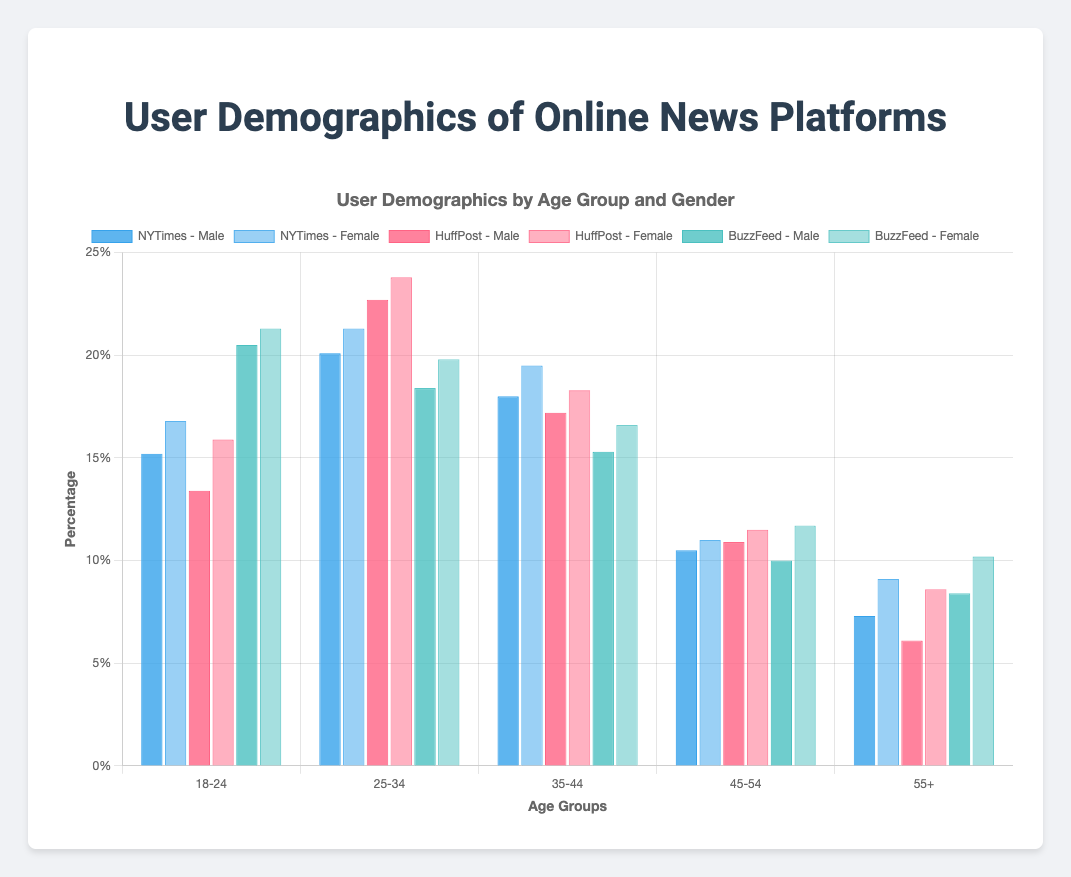Which platform has the highest percentage of users in the 18-24 age group for both genders combined? To find the platform with the highest percentage of users in the 18-24 age group for both genders combined, add the percentages for males and females for each platform in this age group. For NYTimes, it's 15.2% (male) + 16.8% (female) = 32%. For HuffPost, it's 13.4% (male) + 15.9% (female) = 29.3%. For BuzzFeed, it's 20.5% (male) + 21.3% (female) = 41.8%. Therefore, BuzzFeed has the highest percentage in this age group.
Answer: BuzzFeed Compare the percentage of female users aged 55+ across the three platforms and identify which one has the highest percentage. Each platform's percentage of female users aged 55+ is as follows: NYTimes (9.1%), HuffPost (8.6%), and BuzzFeed (10.2%). Therefore, BuzzFeed has the highest percentage of female users in this age group.
Answer: BuzzFeed What is the combined percentage of male users aged 35-44 across all platforms? To find the combined percentage of male users aged 35-44, add the percentages from all three platforms: NYTimes (18.0%), HuffPost (17.2%), and BuzzFeed (15.3%). Thus, the combined percentage is 18.0% + 17.2% + 15.3% = 50.5%.
Answer: 50.5% What is the visual color representation for BuzzFeed male users? The bars representing male users for BuzzFeed are in shades of blue-green. Specifically, it's the brighter blue-green for male users.
Answer: Blue-green Compare the percentage of total users (both genders) in the 55+ age group between NYTimes and HuffPost. Which platform has a higher total percentage? Calculate each platform's total percentage for the 55+ age group by adding male and female percentages. NYTimes: 7.3% (male) + 9.1% (female) = 16.4%. HuffPost: 6.1% (male) + 8.6% (female) = 14.7%. NYTimes has a higher total percentage.
Answer: NYTimes 